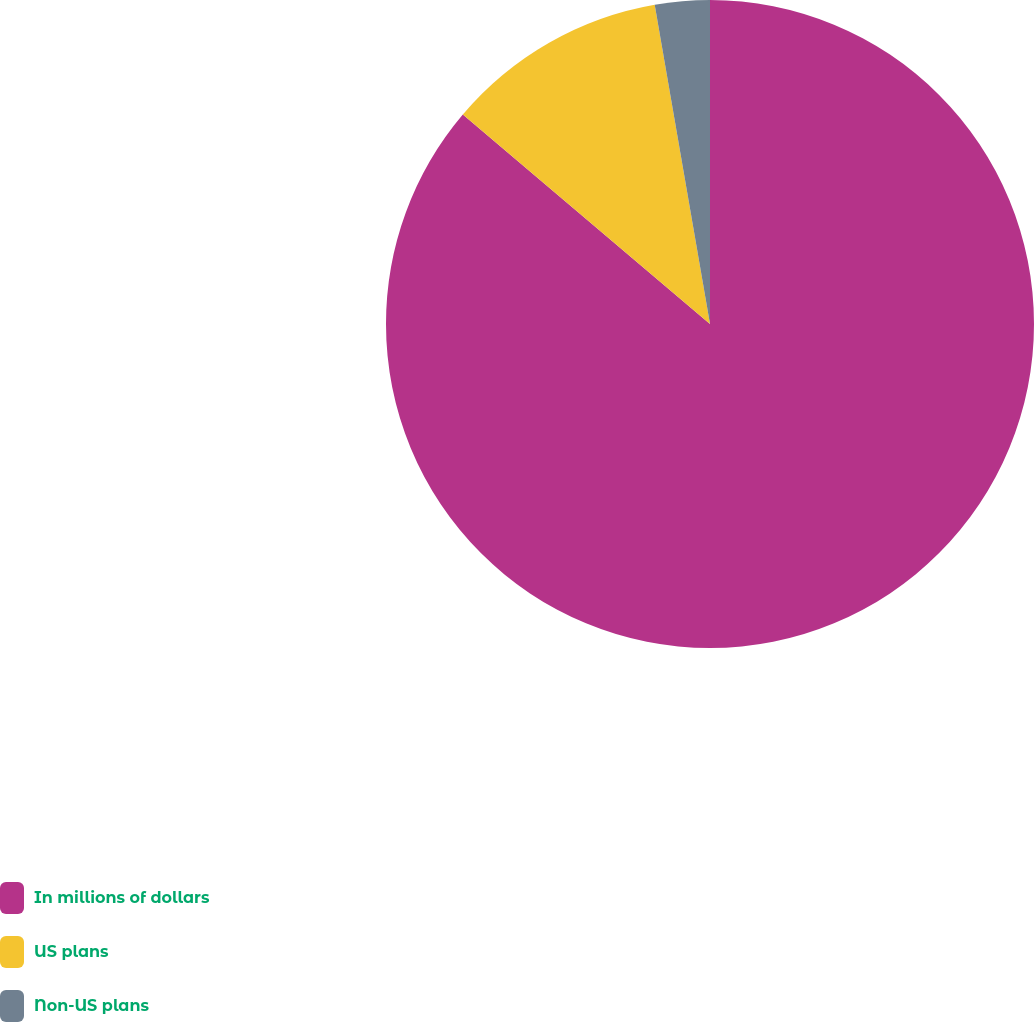Convert chart. <chart><loc_0><loc_0><loc_500><loc_500><pie_chart><fcel>In millions of dollars<fcel>US plans<fcel>Non-US plans<nl><fcel>86.19%<fcel>11.08%<fcel>2.73%<nl></chart> 